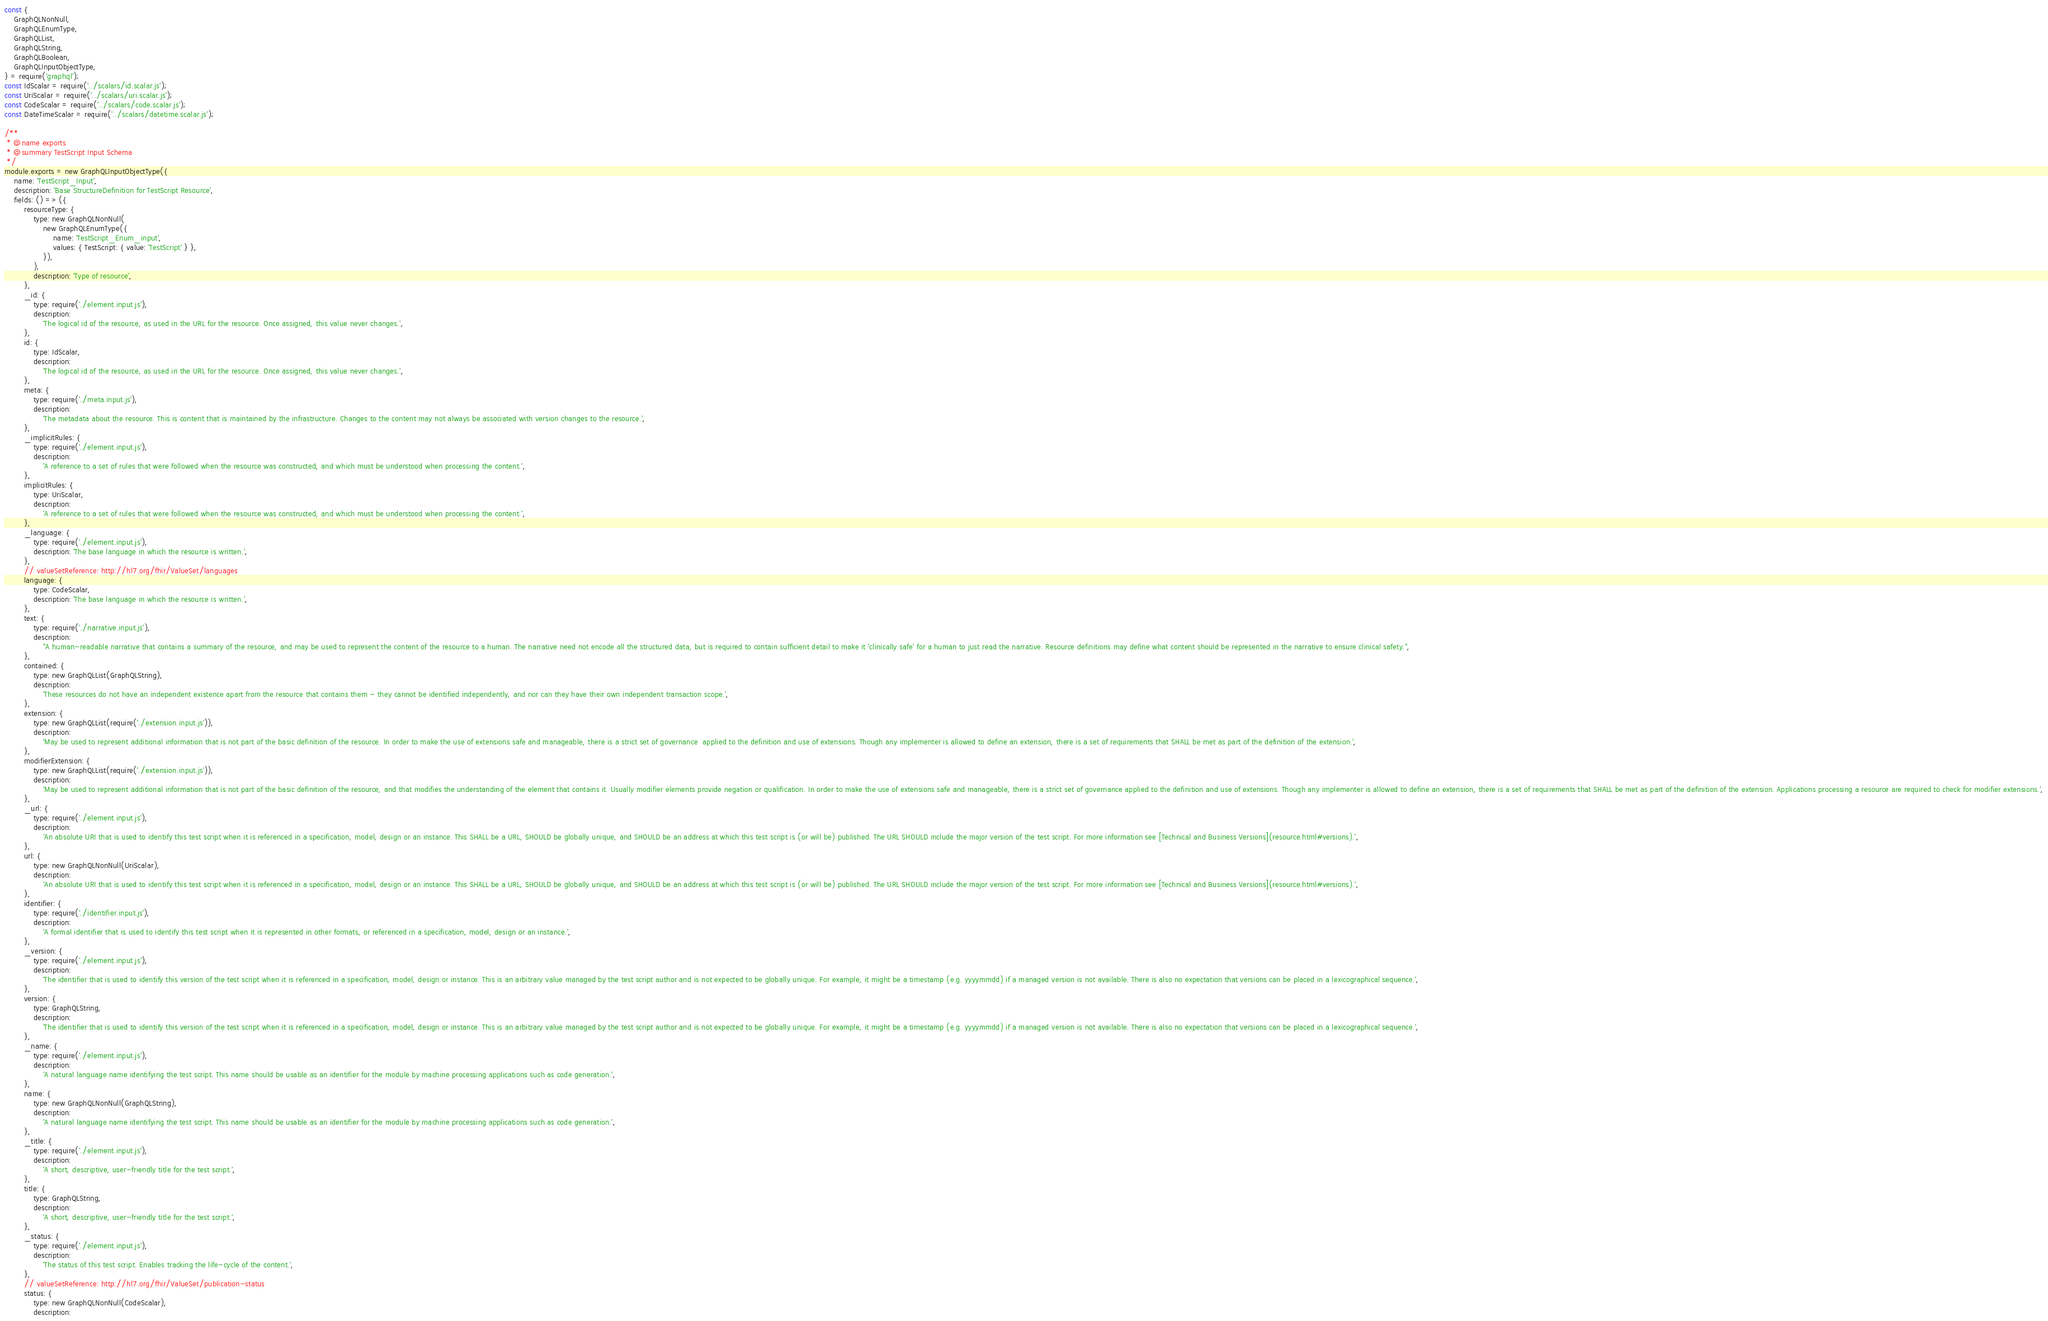<code> <loc_0><loc_0><loc_500><loc_500><_JavaScript_>const {
	GraphQLNonNull,
	GraphQLEnumType,
	GraphQLList,
	GraphQLString,
	GraphQLBoolean,
	GraphQLInputObjectType,
} = require('graphql');
const IdScalar = require('../scalars/id.scalar.js');
const UriScalar = require('../scalars/uri.scalar.js');
const CodeScalar = require('../scalars/code.scalar.js');
const DateTimeScalar = require('../scalars/datetime.scalar.js');

/**
 * @name exports
 * @summary TestScript Input Schema
 */
module.exports = new GraphQLInputObjectType({
	name: 'TestScript_Input',
	description: 'Base StructureDefinition for TestScript Resource',
	fields: () => ({
		resourceType: {
			type: new GraphQLNonNull(
				new GraphQLEnumType({
					name: 'TestScript_Enum_input',
					values: { TestScript: { value: 'TestScript' } },
				}),
			),
			description: 'Type of resource',
		},
		_id: {
			type: require('./element.input.js'),
			description:
				'The logical id of the resource, as used in the URL for the resource. Once assigned, this value never changes.',
		},
		id: {
			type: IdScalar,
			description:
				'The logical id of the resource, as used in the URL for the resource. Once assigned, this value never changes.',
		},
		meta: {
			type: require('./meta.input.js'),
			description:
				'The metadata about the resource. This is content that is maintained by the infrastructure. Changes to the content may not always be associated with version changes to the resource.',
		},
		_implicitRules: {
			type: require('./element.input.js'),
			description:
				'A reference to a set of rules that were followed when the resource was constructed, and which must be understood when processing the content.',
		},
		implicitRules: {
			type: UriScalar,
			description:
				'A reference to a set of rules that were followed when the resource was constructed, and which must be understood when processing the content.',
		},
		_language: {
			type: require('./element.input.js'),
			description: 'The base language in which the resource is written.',
		},
		// valueSetReference: http://hl7.org/fhir/ValueSet/languages
		language: {
			type: CodeScalar,
			description: 'The base language in which the resource is written.',
		},
		text: {
			type: require('./narrative.input.js'),
			description:
				"A human-readable narrative that contains a summary of the resource, and may be used to represent the content of the resource to a human. The narrative need not encode all the structured data, but is required to contain sufficient detail to make it 'clinically safe' for a human to just read the narrative. Resource definitions may define what content should be represented in the narrative to ensure clinical safety.",
		},
		contained: {
			type: new GraphQLList(GraphQLString),
			description:
				'These resources do not have an independent existence apart from the resource that contains them - they cannot be identified independently, and nor can they have their own independent transaction scope.',
		},
		extension: {
			type: new GraphQLList(require('./extension.input.js')),
			description:
				'May be used to represent additional information that is not part of the basic definition of the resource. In order to make the use of extensions safe and manageable, there is a strict set of governance  applied to the definition and use of extensions. Though any implementer is allowed to define an extension, there is a set of requirements that SHALL be met as part of the definition of the extension.',
		},
		modifierExtension: {
			type: new GraphQLList(require('./extension.input.js')),
			description:
				'May be used to represent additional information that is not part of the basic definition of the resource, and that modifies the understanding of the element that contains it. Usually modifier elements provide negation or qualification. In order to make the use of extensions safe and manageable, there is a strict set of governance applied to the definition and use of extensions. Though any implementer is allowed to define an extension, there is a set of requirements that SHALL be met as part of the definition of the extension. Applications processing a resource are required to check for modifier extensions.',
		},
		_url: {
			type: require('./element.input.js'),
			description:
				'An absolute URI that is used to identify this test script when it is referenced in a specification, model, design or an instance. This SHALL be a URL, SHOULD be globally unique, and SHOULD be an address at which this test script is (or will be) published. The URL SHOULD include the major version of the test script. For more information see [Technical and Business Versions](resource.html#versions).',
		},
		url: {
			type: new GraphQLNonNull(UriScalar),
			description:
				'An absolute URI that is used to identify this test script when it is referenced in a specification, model, design or an instance. This SHALL be a URL, SHOULD be globally unique, and SHOULD be an address at which this test script is (or will be) published. The URL SHOULD include the major version of the test script. For more information see [Technical and Business Versions](resource.html#versions).',
		},
		identifier: {
			type: require('./identifier.input.js'),
			description:
				'A formal identifier that is used to identify this test script when it is represented in other formats, or referenced in a specification, model, design or an instance.',
		},
		_version: {
			type: require('./element.input.js'),
			description:
				'The identifier that is used to identify this version of the test script when it is referenced in a specification, model, design or instance. This is an arbitrary value managed by the test script author and is not expected to be globally unique. For example, it might be a timestamp (e.g. yyyymmdd) if a managed version is not available. There is also no expectation that versions can be placed in a lexicographical sequence.',
		},
		version: {
			type: GraphQLString,
			description:
				'The identifier that is used to identify this version of the test script when it is referenced in a specification, model, design or instance. This is an arbitrary value managed by the test script author and is not expected to be globally unique. For example, it might be a timestamp (e.g. yyyymmdd) if a managed version is not available. There is also no expectation that versions can be placed in a lexicographical sequence.',
		},
		_name: {
			type: require('./element.input.js'),
			description:
				'A natural language name identifying the test script. This name should be usable as an identifier for the module by machine processing applications such as code generation.',
		},
		name: {
			type: new GraphQLNonNull(GraphQLString),
			description:
				'A natural language name identifying the test script. This name should be usable as an identifier for the module by machine processing applications such as code generation.',
		},
		_title: {
			type: require('./element.input.js'),
			description:
				'A short, descriptive, user-friendly title for the test script.',
		},
		title: {
			type: GraphQLString,
			description:
				'A short, descriptive, user-friendly title for the test script.',
		},
		_status: {
			type: require('./element.input.js'),
			description:
				'The status of this test script. Enables tracking the life-cycle of the content.',
		},
		// valueSetReference: http://hl7.org/fhir/ValueSet/publication-status
		status: {
			type: new GraphQLNonNull(CodeScalar),
			description:</code> 